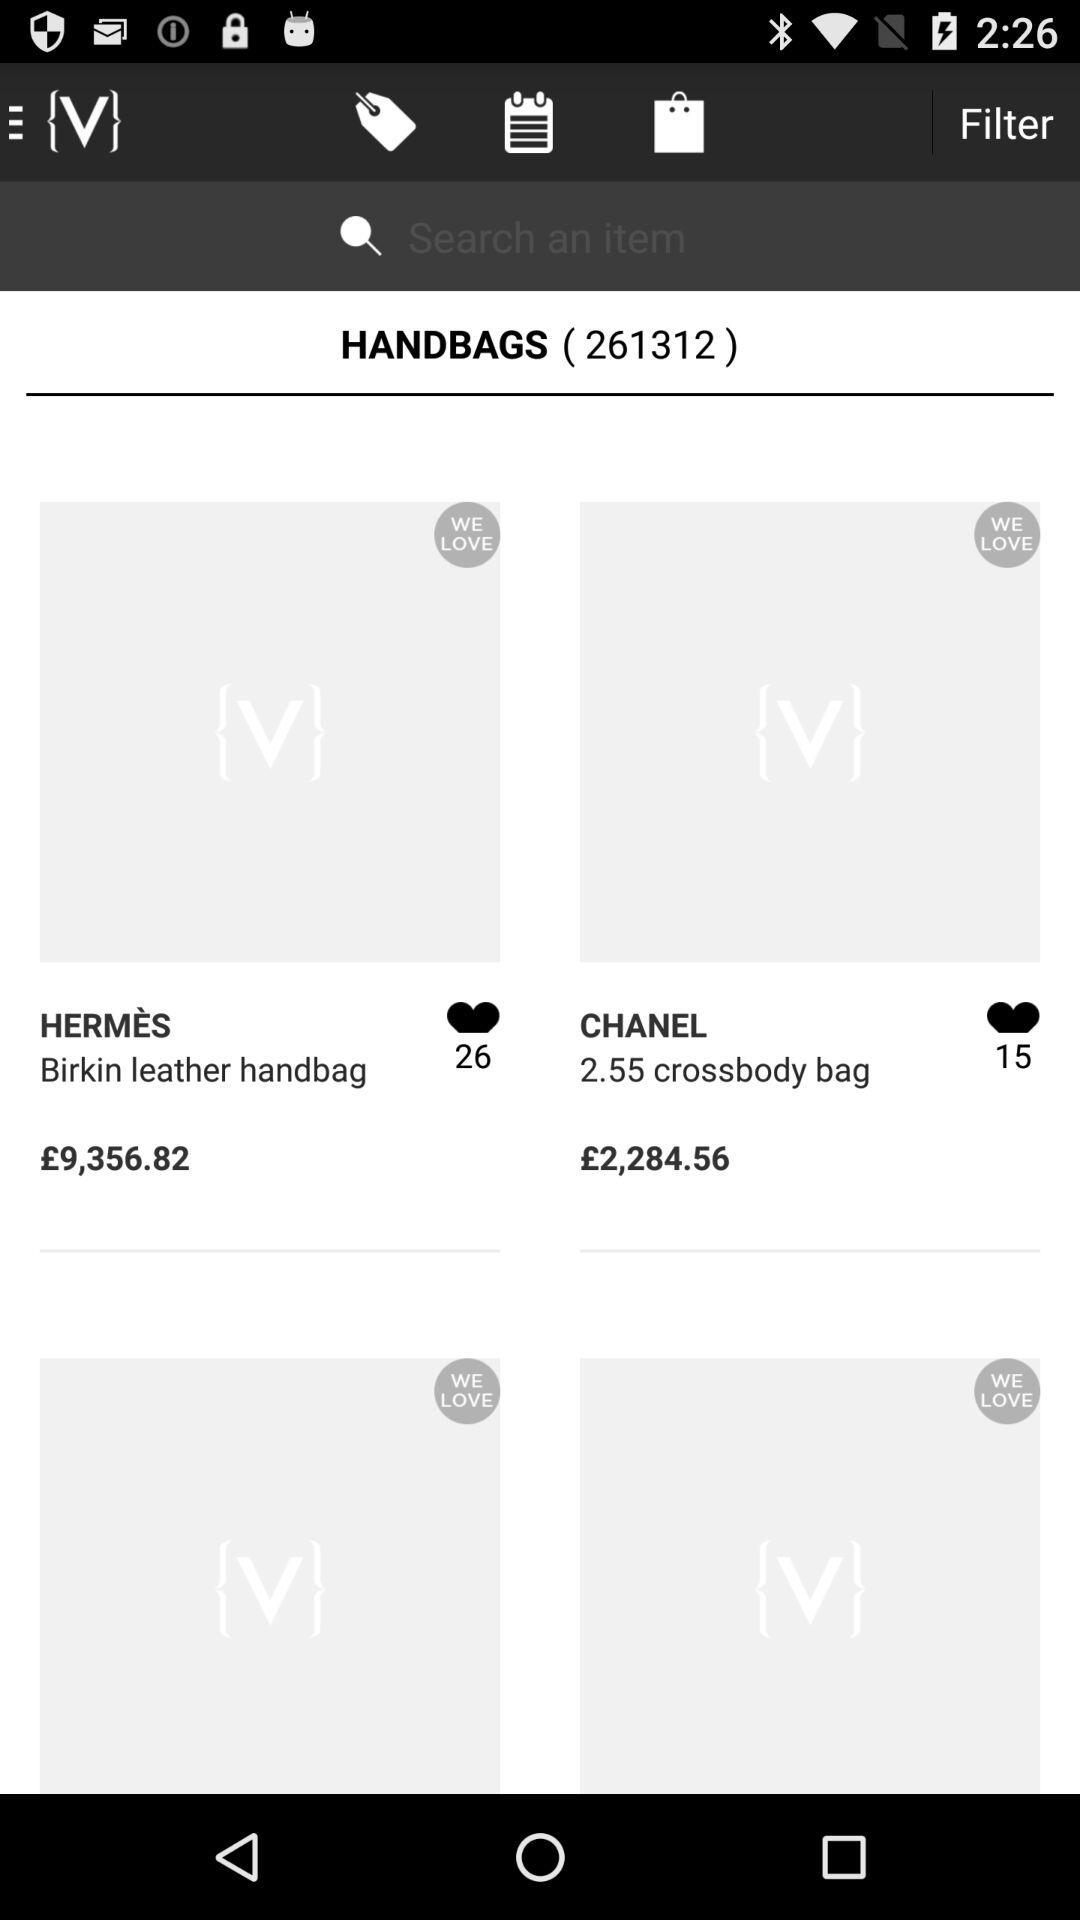How many more hearts does the item with the text 'Birkin leather handbag' have than the item with the text '2.55 crossbody bag'?
Answer the question using a single word or phrase. 11 